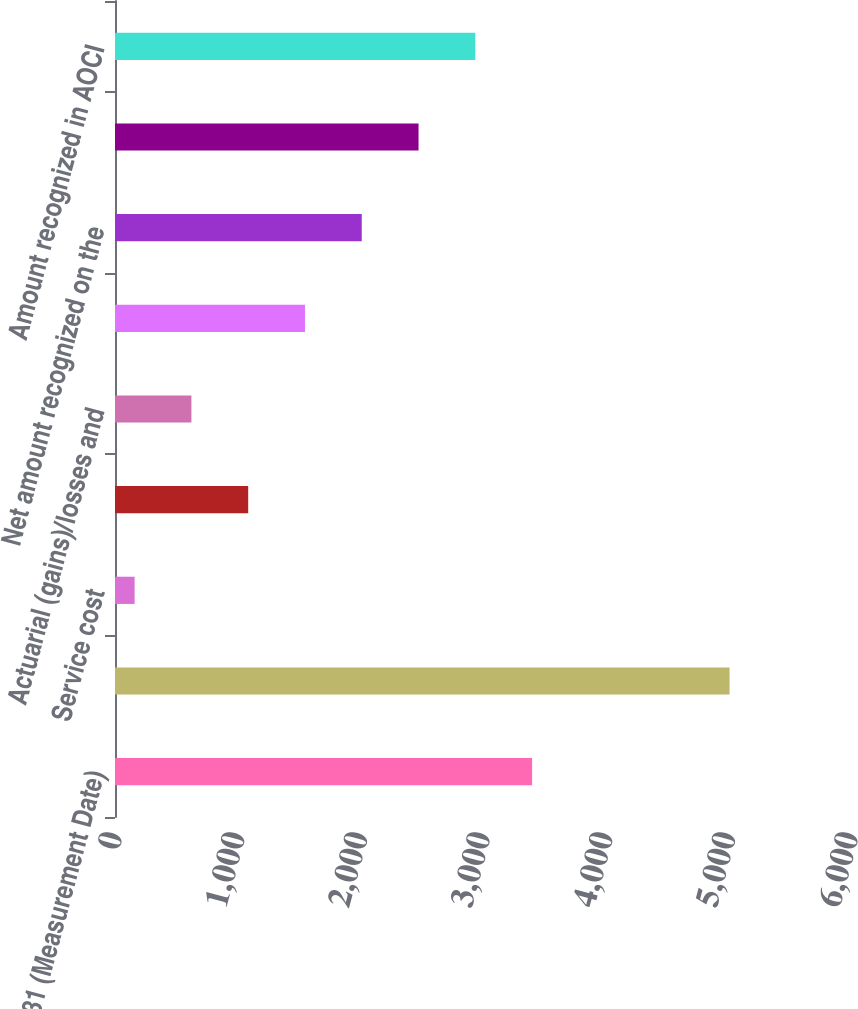Convert chart. <chart><loc_0><loc_0><loc_500><loc_500><bar_chart><fcel>December 31 (Measurement Date)<fcel>Projected benefit obligation<fcel>Service cost<fcel>Interest cost<fcel>Actuarial (gains)/losses and<fcel>Benefits paid<fcel>Net amount recognized on the<fcel>Net actuarial loss<fcel>Amount recognized in AOCI<nl><fcel>3400.3<fcel>5009.9<fcel>160<fcel>1085.8<fcel>622.9<fcel>1548.7<fcel>2011.6<fcel>2474.5<fcel>2937.4<nl></chart> 